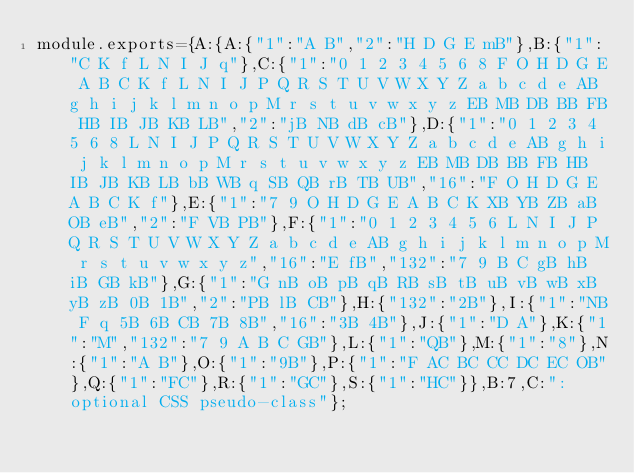<code> <loc_0><loc_0><loc_500><loc_500><_JavaScript_>module.exports={A:{A:{"1":"A B","2":"H D G E mB"},B:{"1":"C K f L N I J q"},C:{"1":"0 1 2 3 4 5 6 8 F O H D G E A B C K f L N I J P Q R S T U V W X Y Z a b c d e AB g h i j k l m n o p M r s t u v w x y z EB MB DB BB FB HB IB JB KB LB","2":"jB NB dB cB"},D:{"1":"0 1 2 3 4 5 6 8 L N I J P Q R S T U V W X Y Z a b c d e AB g h i j k l m n o p M r s t u v w x y z EB MB DB BB FB HB IB JB KB LB bB WB q SB QB rB TB UB","16":"F O H D G E A B C K f"},E:{"1":"7 9 O H D G E A B C K XB YB ZB aB OB eB","2":"F VB PB"},F:{"1":"0 1 2 3 4 5 6 L N I J P Q R S T U V W X Y Z a b c d e AB g h i j k l m n o p M r s t u v w x y z","16":"E fB","132":"7 9 B C gB hB iB GB kB"},G:{"1":"G nB oB pB qB RB sB tB uB vB wB xB yB zB 0B 1B","2":"PB lB CB"},H:{"132":"2B"},I:{"1":"NB F q 5B 6B CB 7B 8B","16":"3B 4B"},J:{"1":"D A"},K:{"1":"M","132":"7 9 A B C GB"},L:{"1":"QB"},M:{"1":"8"},N:{"1":"A B"},O:{"1":"9B"},P:{"1":"F AC BC CC DC EC OB"},Q:{"1":"FC"},R:{"1":"GC"},S:{"1":"HC"}},B:7,C:":optional CSS pseudo-class"};
</code> 